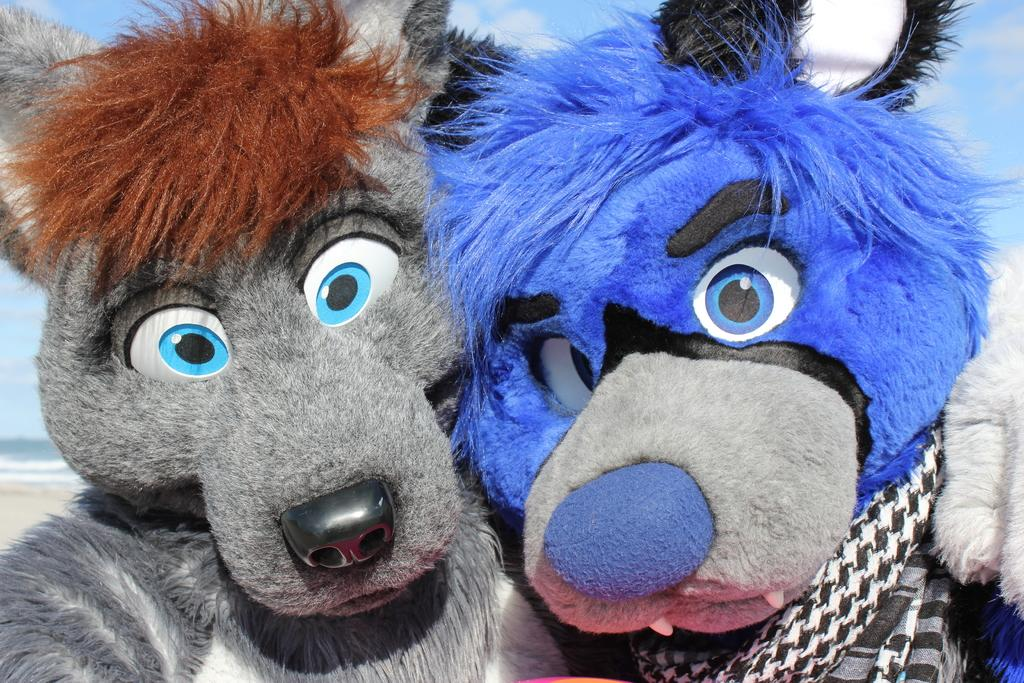How many toys are present in the image? There are two toys in the image. Can you describe the color or pattern of the first toy? One of the toys is blue. What can be said about the appearance of the second toy? The other toy is hashed, possibly with a pattern or color. What flavor of ice cream is being served with the toys in the image? There is no ice cream present in the image, only two toys. 